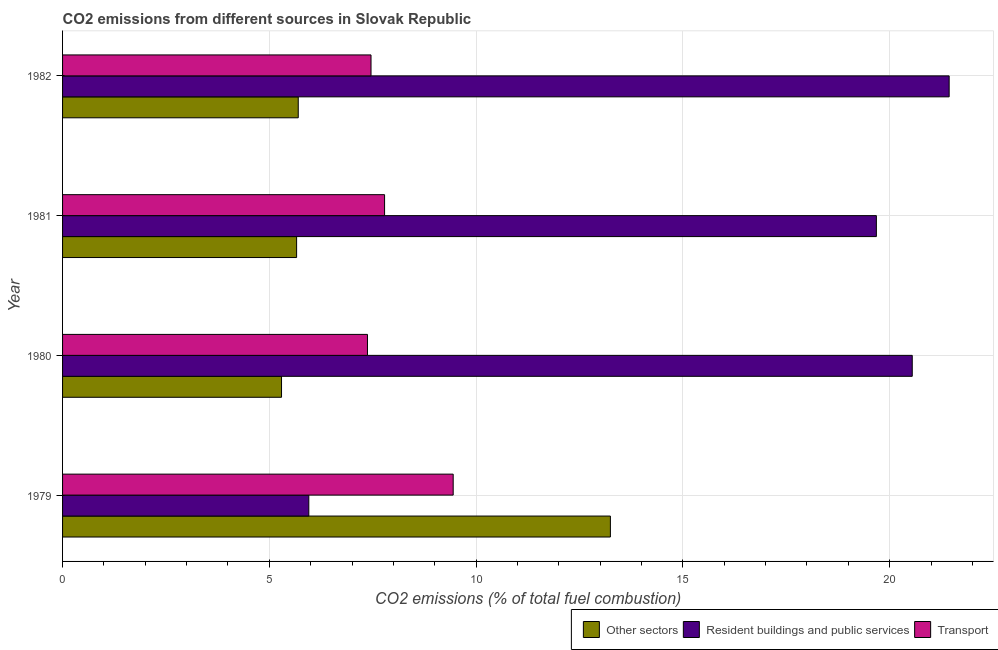How many different coloured bars are there?
Provide a succinct answer. 3. Are the number of bars per tick equal to the number of legend labels?
Offer a terse response. Yes. How many bars are there on the 3rd tick from the top?
Your answer should be very brief. 3. What is the label of the 2nd group of bars from the top?
Offer a very short reply. 1981. What is the percentage of co2 emissions from resident buildings and public services in 1979?
Offer a terse response. 5.95. Across all years, what is the maximum percentage of co2 emissions from transport?
Your answer should be compact. 9.45. Across all years, what is the minimum percentage of co2 emissions from transport?
Give a very brief answer. 7.37. In which year was the percentage of co2 emissions from resident buildings and public services minimum?
Offer a very short reply. 1979. What is the total percentage of co2 emissions from resident buildings and public services in the graph?
Your answer should be very brief. 67.62. What is the difference between the percentage of co2 emissions from other sectors in 1981 and that in 1982?
Your answer should be very brief. -0.04. What is the difference between the percentage of co2 emissions from resident buildings and public services in 1980 and the percentage of co2 emissions from other sectors in 1982?
Your response must be concise. 14.85. What is the average percentage of co2 emissions from resident buildings and public services per year?
Provide a short and direct response. 16.9. In the year 1979, what is the difference between the percentage of co2 emissions from resident buildings and public services and percentage of co2 emissions from other sectors?
Your response must be concise. -7.29. What is the ratio of the percentage of co2 emissions from resident buildings and public services in 1979 to that in 1981?
Provide a short and direct response. 0.3. Is the difference between the percentage of co2 emissions from other sectors in 1980 and 1981 greater than the difference between the percentage of co2 emissions from transport in 1980 and 1981?
Give a very brief answer. Yes. What is the difference between the highest and the second highest percentage of co2 emissions from transport?
Ensure brevity in your answer.  1.66. What is the difference between the highest and the lowest percentage of co2 emissions from transport?
Keep it short and to the point. 2.07. In how many years, is the percentage of co2 emissions from other sectors greater than the average percentage of co2 emissions from other sectors taken over all years?
Your answer should be compact. 1. What does the 2nd bar from the top in 1979 represents?
Your answer should be compact. Resident buildings and public services. What does the 3rd bar from the bottom in 1979 represents?
Keep it short and to the point. Transport. How many bars are there?
Offer a terse response. 12. Does the graph contain grids?
Provide a short and direct response. Yes. Where does the legend appear in the graph?
Keep it short and to the point. Bottom right. How many legend labels are there?
Your answer should be very brief. 3. How are the legend labels stacked?
Give a very brief answer. Horizontal. What is the title of the graph?
Offer a terse response. CO2 emissions from different sources in Slovak Republic. Does "Grants" appear as one of the legend labels in the graph?
Your response must be concise. No. What is the label or title of the X-axis?
Your answer should be compact. CO2 emissions (% of total fuel combustion). What is the label or title of the Y-axis?
Your answer should be very brief. Year. What is the CO2 emissions (% of total fuel combustion) of Other sectors in 1979?
Provide a short and direct response. 13.25. What is the CO2 emissions (% of total fuel combustion) in Resident buildings and public services in 1979?
Ensure brevity in your answer.  5.95. What is the CO2 emissions (% of total fuel combustion) of Transport in 1979?
Offer a terse response. 9.45. What is the CO2 emissions (% of total fuel combustion) in Other sectors in 1980?
Your response must be concise. 5.29. What is the CO2 emissions (% of total fuel combustion) of Resident buildings and public services in 1980?
Keep it short and to the point. 20.55. What is the CO2 emissions (% of total fuel combustion) in Transport in 1980?
Your response must be concise. 7.37. What is the CO2 emissions (% of total fuel combustion) of Other sectors in 1981?
Keep it short and to the point. 5.66. What is the CO2 emissions (% of total fuel combustion) of Resident buildings and public services in 1981?
Your response must be concise. 19.68. What is the CO2 emissions (% of total fuel combustion) of Transport in 1981?
Ensure brevity in your answer.  7.79. What is the CO2 emissions (% of total fuel combustion) in Other sectors in 1982?
Offer a very short reply. 5.7. What is the CO2 emissions (% of total fuel combustion) in Resident buildings and public services in 1982?
Your response must be concise. 21.44. What is the CO2 emissions (% of total fuel combustion) of Transport in 1982?
Your answer should be very brief. 7.46. Across all years, what is the maximum CO2 emissions (% of total fuel combustion) in Other sectors?
Your response must be concise. 13.25. Across all years, what is the maximum CO2 emissions (% of total fuel combustion) in Resident buildings and public services?
Your answer should be compact. 21.44. Across all years, what is the maximum CO2 emissions (% of total fuel combustion) in Transport?
Give a very brief answer. 9.45. Across all years, what is the minimum CO2 emissions (% of total fuel combustion) in Other sectors?
Provide a succinct answer. 5.29. Across all years, what is the minimum CO2 emissions (% of total fuel combustion) in Resident buildings and public services?
Ensure brevity in your answer.  5.95. Across all years, what is the minimum CO2 emissions (% of total fuel combustion) of Transport?
Your response must be concise. 7.37. What is the total CO2 emissions (% of total fuel combustion) in Other sectors in the graph?
Your answer should be very brief. 29.9. What is the total CO2 emissions (% of total fuel combustion) in Resident buildings and public services in the graph?
Your response must be concise. 67.62. What is the total CO2 emissions (% of total fuel combustion) in Transport in the graph?
Make the answer very short. 32.06. What is the difference between the CO2 emissions (% of total fuel combustion) of Other sectors in 1979 and that in 1980?
Provide a succinct answer. 7.95. What is the difference between the CO2 emissions (% of total fuel combustion) in Resident buildings and public services in 1979 and that in 1980?
Your response must be concise. -14.59. What is the difference between the CO2 emissions (% of total fuel combustion) in Transport in 1979 and that in 1980?
Provide a succinct answer. 2.07. What is the difference between the CO2 emissions (% of total fuel combustion) in Other sectors in 1979 and that in 1981?
Your response must be concise. 7.59. What is the difference between the CO2 emissions (% of total fuel combustion) in Resident buildings and public services in 1979 and that in 1981?
Offer a terse response. -13.72. What is the difference between the CO2 emissions (% of total fuel combustion) in Transport in 1979 and that in 1981?
Your answer should be compact. 1.66. What is the difference between the CO2 emissions (% of total fuel combustion) in Other sectors in 1979 and that in 1982?
Give a very brief answer. 7.55. What is the difference between the CO2 emissions (% of total fuel combustion) of Resident buildings and public services in 1979 and that in 1982?
Keep it short and to the point. -15.48. What is the difference between the CO2 emissions (% of total fuel combustion) of Transport in 1979 and that in 1982?
Your answer should be very brief. 1.99. What is the difference between the CO2 emissions (% of total fuel combustion) in Other sectors in 1980 and that in 1981?
Your answer should be very brief. -0.36. What is the difference between the CO2 emissions (% of total fuel combustion) of Resident buildings and public services in 1980 and that in 1981?
Your answer should be compact. 0.87. What is the difference between the CO2 emissions (% of total fuel combustion) in Transport in 1980 and that in 1981?
Your answer should be very brief. -0.41. What is the difference between the CO2 emissions (% of total fuel combustion) of Other sectors in 1980 and that in 1982?
Your answer should be very brief. -0.4. What is the difference between the CO2 emissions (% of total fuel combustion) of Resident buildings and public services in 1980 and that in 1982?
Offer a very short reply. -0.89. What is the difference between the CO2 emissions (% of total fuel combustion) in Transport in 1980 and that in 1982?
Your answer should be very brief. -0.09. What is the difference between the CO2 emissions (% of total fuel combustion) of Other sectors in 1981 and that in 1982?
Keep it short and to the point. -0.04. What is the difference between the CO2 emissions (% of total fuel combustion) of Resident buildings and public services in 1981 and that in 1982?
Offer a very short reply. -1.76. What is the difference between the CO2 emissions (% of total fuel combustion) of Transport in 1981 and that in 1982?
Your answer should be compact. 0.33. What is the difference between the CO2 emissions (% of total fuel combustion) of Other sectors in 1979 and the CO2 emissions (% of total fuel combustion) of Resident buildings and public services in 1980?
Your answer should be compact. -7.3. What is the difference between the CO2 emissions (% of total fuel combustion) of Other sectors in 1979 and the CO2 emissions (% of total fuel combustion) of Transport in 1980?
Your answer should be compact. 5.87. What is the difference between the CO2 emissions (% of total fuel combustion) in Resident buildings and public services in 1979 and the CO2 emissions (% of total fuel combustion) in Transport in 1980?
Keep it short and to the point. -1.42. What is the difference between the CO2 emissions (% of total fuel combustion) in Other sectors in 1979 and the CO2 emissions (% of total fuel combustion) in Resident buildings and public services in 1981?
Ensure brevity in your answer.  -6.43. What is the difference between the CO2 emissions (% of total fuel combustion) in Other sectors in 1979 and the CO2 emissions (% of total fuel combustion) in Transport in 1981?
Offer a terse response. 5.46. What is the difference between the CO2 emissions (% of total fuel combustion) of Resident buildings and public services in 1979 and the CO2 emissions (% of total fuel combustion) of Transport in 1981?
Give a very brief answer. -1.83. What is the difference between the CO2 emissions (% of total fuel combustion) of Other sectors in 1979 and the CO2 emissions (% of total fuel combustion) of Resident buildings and public services in 1982?
Your answer should be very brief. -8.19. What is the difference between the CO2 emissions (% of total fuel combustion) of Other sectors in 1979 and the CO2 emissions (% of total fuel combustion) of Transport in 1982?
Your answer should be very brief. 5.79. What is the difference between the CO2 emissions (% of total fuel combustion) in Resident buildings and public services in 1979 and the CO2 emissions (% of total fuel combustion) in Transport in 1982?
Offer a very short reply. -1.5. What is the difference between the CO2 emissions (% of total fuel combustion) of Other sectors in 1980 and the CO2 emissions (% of total fuel combustion) of Resident buildings and public services in 1981?
Provide a succinct answer. -14.38. What is the difference between the CO2 emissions (% of total fuel combustion) of Other sectors in 1980 and the CO2 emissions (% of total fuel combustion) of Transport in 1981?
Offer a very short reply. -2.49. What is the difference between the CO2 emissions (% of total fuel combustion) in Resident buildings and public services in 1980 and the CO2 emissions (% of total fuel combustion) in Transport in 1981?
Offer a terse response. 12.76. What is the difference between the CO2 emissions (% of total fuel combustion) in Other sectors in 1980 and the CO2 emissions (% of total fuel combustion) in Resident buildings and public services in 1982?
Offer a very short reply. -16.14. What is the difference between the CO2 emissions (% of total fuel combustion) of Other sectors in 1980 and the CO2 emissions (% of total fuel combustion) of Transport in 1982?
Your answer should be compact. -2.16. What is the difference between the CO2 emissions (% of total fuel combustion) of Resident buildings and public services in 1980 and the CO2 emissions (% of total fuel combustion) of Transport in 1982?
Provide a short and direct response. 13.09. What is the difference between the CO2 emissions (% of total fuel combustion) of Other sectors in 1981 and the CO2 emissions (% of total fuel combustion) of Resident buildings and public services in 1982?
Keep it short and to the point. -15.78. What is the difference between the CO2 emissions (% of total fuel combustion) in Other sectors in 1981 and the CO2 emissions (% of total fuel combustion) in Transport in 1982?
Your answer should be compact. -1.8. What is the difference between the CO2 emissions (% of total fuel combustion) in Resident buildings and public services in 1981 and the CO2 emissions (% of total fuel combustion) in Transport in 1982?
Your response must be concise. 12.22. What is the average CO2 emissions (% of total fuel combustion) in Other sectors per year?
Give a very brief answer. 7.47. What is the average CO2 emissions (% of total fuel combustion) of Resident buildings and public services per year?
Offer a terse response. 16.9. What is the average CO2 emissions (% of total fuel combustion) of Transport per year?
Your response must be concise. 8.02. In the year 1979, what is the difference between the CO2 emissions (% of total fuel combustion) of Other sectors and CO2 emissions (% of total fuel combustion) of Resident buildings and public services?
Provide a succinct answer. 7.29. In the year 1979, what is the difference between the CO2 emissions (% of total fuel combustion) of Other sectors and CO2 emissions (% of total fuel combustion) of Transport?
Keep it short and to the point. 3.8. In the year 1979, what is the difference between the CO2 emissions (% of total fuel combustion) of Resident buildings and public services and CO2 emissions (% of total fuel combustion) of Transport?
Provide a short and direct response. -3.49. In the year 1980, what is the difference between the CO2 emissions (% of total fuel combustion) in Other sectors and CO2 emissions (% of total fuel combustion) in Resident buildings and public services?
Give a very brief answer. -15.25. In the year 1980, what is the difference between the CO2 emissions (% of total fuel combustion) in Other sectors and CO2 emissions (% of total fuel combustion) in Transport?
Your answer should be very brief. -2.08. In the year 1980, what is the difference between the CO2 emissions (% of total fuel combustion) in Resident buildings and public services and CO2 emissions (% of total fuel combustion) in Transport?
Offer a terse response. 13.17. In the year 1981, what is the difference between the CO2 emissions (% of total fuel combustion) in Other sectors and CO2 emissions (% of total fuel combustion) in Resident buildings and public services?
Offer a terse response. -14.02. In the year 1981, what is the difference between the CO2 emissions (% of total fuel combustion) in Other sectors and CO2 emissions (% of total fuel combustion) in Transport?
Your response must be concise. -2.13. In the year 1981, what is the difference between the CO2 emissions (% of total fuel combustion) in Resident buildings and public services and CO2 emissions (% of total fuel combustion) in Transport?
Ensure brevity in your answer.  11.89. In the year 1982, what is the difference between the CO2 emissions (% of total fuel combustion) of Other sectors and CO2 emissions (% of total fuel combustion) of Resident buildings and public services?
Keep it short and to the point. -15.74. In the year 1982, what is the difference between the CO2 emissions (% of total fuel combustion) in Other sectors and CO2 emissions (% of total fuel combustion) in Transport?
Keep it short and to the point. -1.76. In the year 1982, what is the difference between the CO2 emissions (% of total fuel combustion) of Resident buildings and public services and CO2 emissions (% of total fuel combustion) of Transport?
Offer a terse response. 13.98. What is the ratio of the CO2 emissions (% of total fuel combustion) of Other sectors in 1979 to that in 1980?
Ensure brevity in your answer.  2.5. What is the ratio of the CO2 emissions (% of total fuel combustion) of Resident buildings and public services in 1979 to that in 1980?
Your answer should be very brief. 0.29. What is the ratio of the CO2 emissions (% of total fuel combustion) of Transport in 1979 to that in 1980?
Keep it short and to the point. 1.28. What is the ratio of the CO2 emissions (% of total fuel combustion) in Other sectors in 1979 to that in 1981?
Offer a terse response. 2.34. What is the ratio of the CO2 emissions (% of total fuel combustion) of Resident buildings and public services in 1979 to that in 1981?
Your answer should be very brief. 0.3. What is the ratio of the CO2 emissions (% of total fuel combustion) of Transport in 1979 to that in 1981?
Keep it short and to the point. 1.21. What is the ratio of the CO2 emissions (% of total fuel combustion) of Other sectors in 1979 to that in 1982?
Offer a very short reply. 2.32. What is the ratio of the CO2 emissions (% of total fuel combustion) in Resident buildings and public services in 1979 to that in 1982?
Your answer should be very brief. 0.28. What is the ratio of the CO2 emissions (% of total fuel combustion) of Transport in 1979 to that in 1982?
Offer a terse response. 1.27. What is the ratio of the CO2 emissions (% of total fuel combustion) of Other sectors in 1980 to that in 1981?
Your response must be concise. 0.94. What is the ratio of the CO2 emissions (% of total fuel combustion) of Resident buildings and public services in 1980 to that in 1981?
Keep it short and to the point. 1.04. What is the ratio of the CO2 emissions (% of total fuel combustion) of Transport in 1980 to that in 1981?
Provide a short and direct response. 0.95. What is the ratio of the CO2 emissions (% of total fuel combustion) in Other sectors in 1980 to that in 1982?
Keep it short and to the point. 0.93. What is the ratio of the CO2 emissions (% of total fuel combustion) in Resident buildings and public services in 1980 to that in 1982?
Your response must be concise. 0.96. What is the ratio of the CO2 emissions (% of total fuel combustion) of Other sectors in 1981 to that in 1982?
Keep it short and to the point. 0.99. What is the ratio of the CO2 emissions (% of total fuel combustion) in Resident buildings and public services in 1981 to that in 1982?
Your response must be concise. 0.92. What is the ratio of the CO2 emissions (% of total fuel combustion) in Transport in 1981 to that in 1982?
Give a very brief answer. 1.04. What is the difference between the highest and the second highest CO2 emissions (% of total fuel combustion) of Other sectors?
Offer a very short reply. 7.55. What is the difference between the highest and the second highest CO2 emissions (% of total fuel combustion) in Resident buildings and public services?
Your answer should be very brief. 0.89. What is the difference between the highest and the second highest CO2 emissions (% of total fuel combustion) in Transport?
Your answer should be compact. 1.66. What is the difference between the highest and the lowest CO2 emissions (% of total fuel combustion) in Other sectors?
Offer a terse response. 7.95. What is the difference between the highest and the lowest CO2 emissions (% of total fuel combustion) in Resident buildings and public services?
Offer a terse response. 15.48. What is the difference between the highest and the lowest CO2 emissions (% of total fuel combustion) in Transport?
Provide a succinct answer. 2.07. 